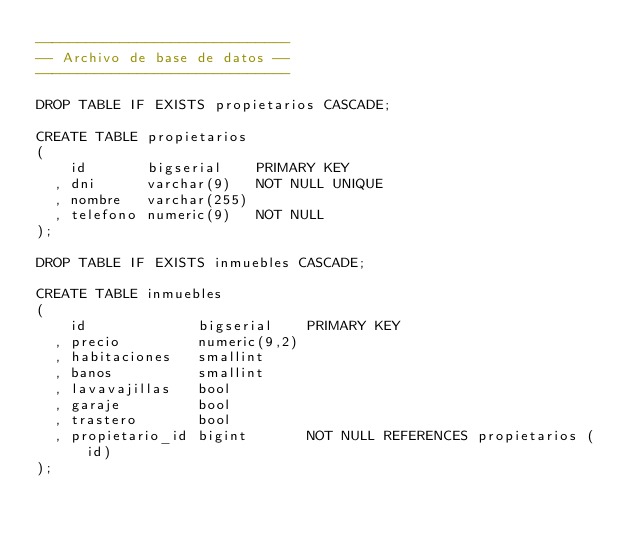<code> <loc_0><loc_0><loc_500><loc_500><_SQL_>------------------------------
-- Archivo de base de datos --
------------------------------

DROP TABLE IF EXISTS propietarios CASCADE;

CREATE TABLE propietarios
(
    id       bigserial    PRIMARY KEY
  , dni      varchar(9)   NOT NULL UNIQUE
  , nombre   varchar(255)
  , telefono numeric(9)   NOT NULL
);

DROP TABLE IF EXISTS inmuebles CASCADE;

CREATE TABLE inmuebles
(
    id             bigserial    PRIMARY KEY
  , precio         numeric(9,2)
  , habitaciones   smallint
  , banos          smallint
  , lavavajillas   bool
  , garaje         bool
  , trastero       bool
  , propietario_id bigint       NOT NULL REFERENCES propietarios (id)
);
</code> 